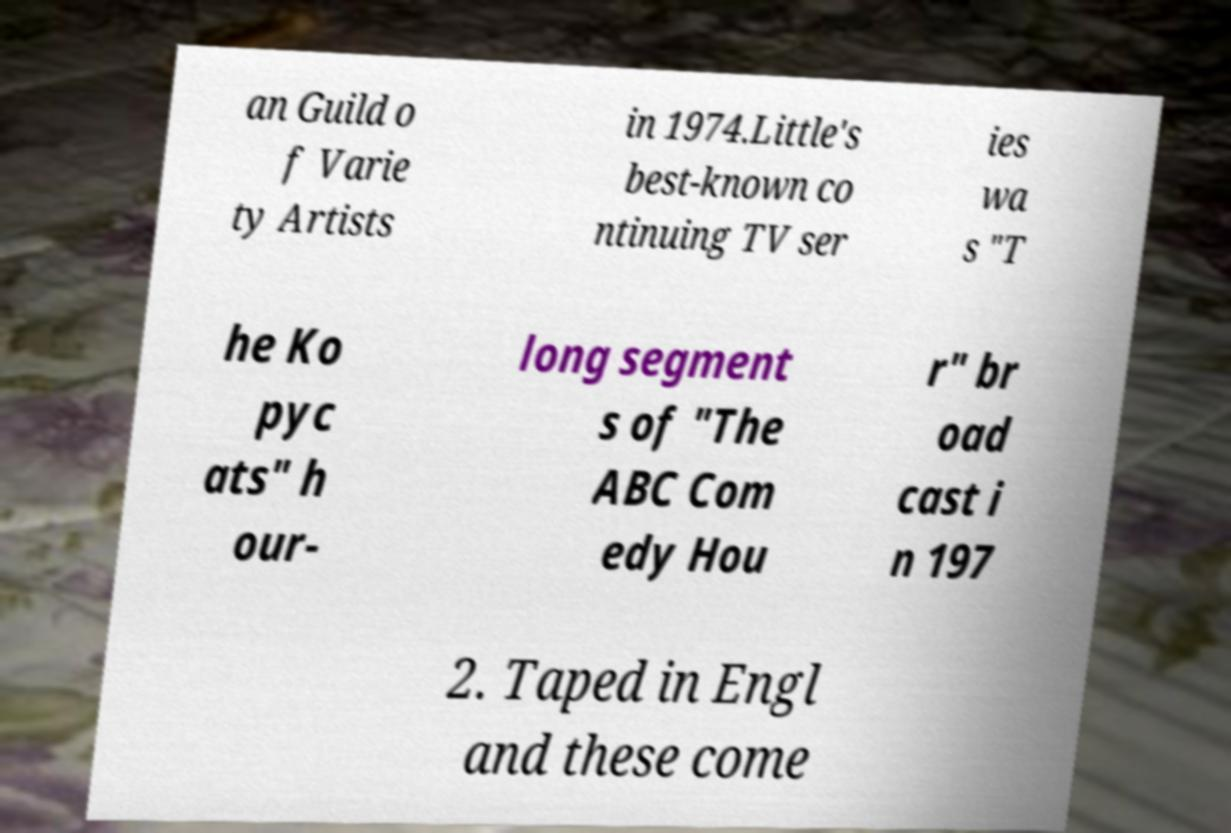I need the written content from this picture converted into text. Can you do that? an Guild o f Varie ty Artists in 1974.Little's best-known co ntinuing TV ser ies wa s "T he Ko pyc ats" h our- long segment s of "The ABC Com edy Hou r" br oad cast i n 197 2. Taped in Engl and these come 